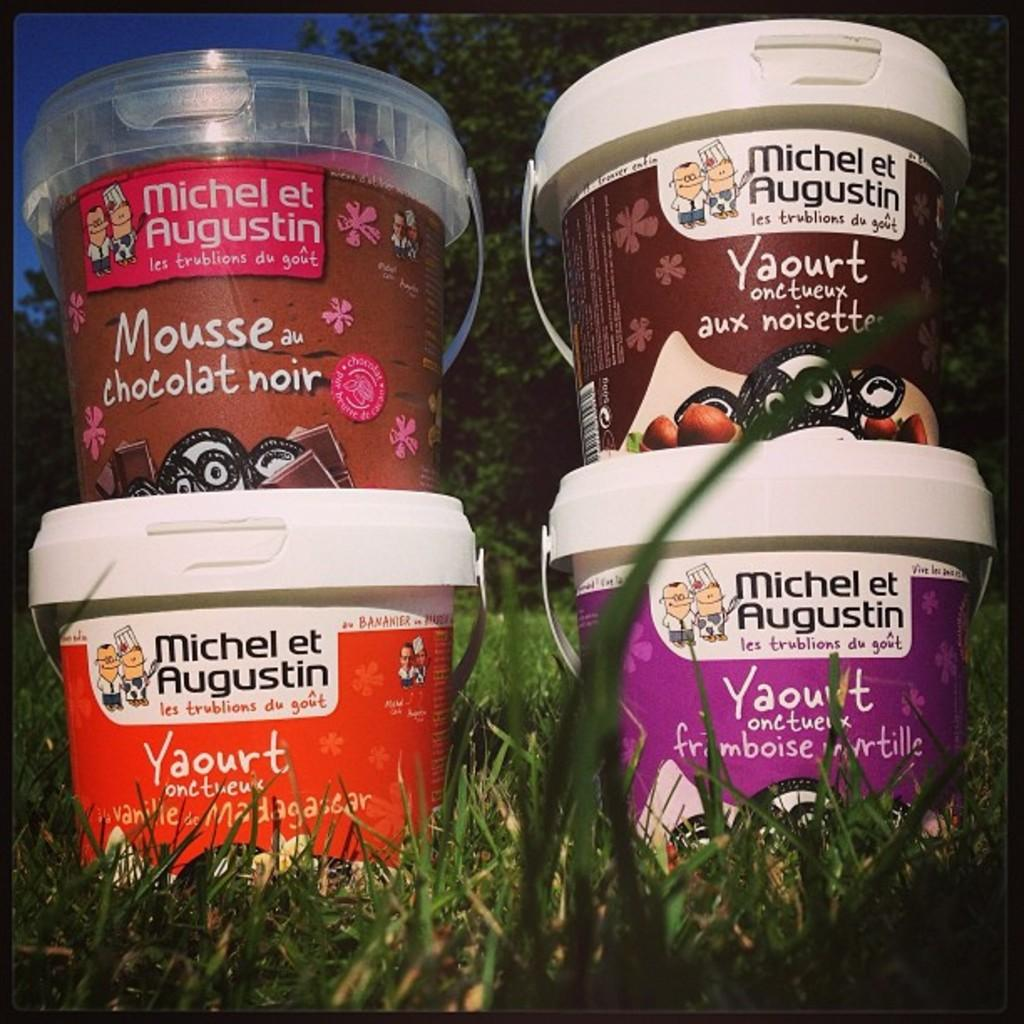What objects are placed on the grassland in the image? There are buckets on the grassland in the image. How are the buckets arranged? The buckets are stacked one upon the other. What can be seen in the background of the image? There are trees in the background of the image. What part of the sky is visible in the image? The sky is visible in the top left corner of the image. What type of engine can be seen in the wilderness in the image? There is no engine present in the image, and the term "wilderness" is not mentioned in the provided facts. 